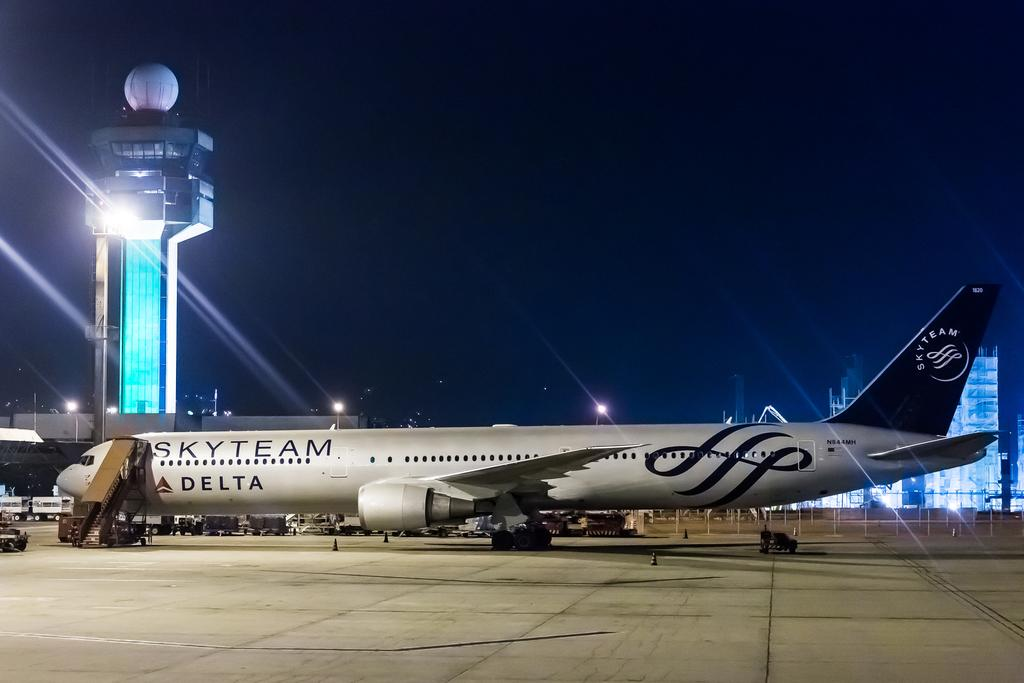Provide a one-sentence caption for the provided image. A Skyteam plane of Delta's sits on the tarmac at an airport. 